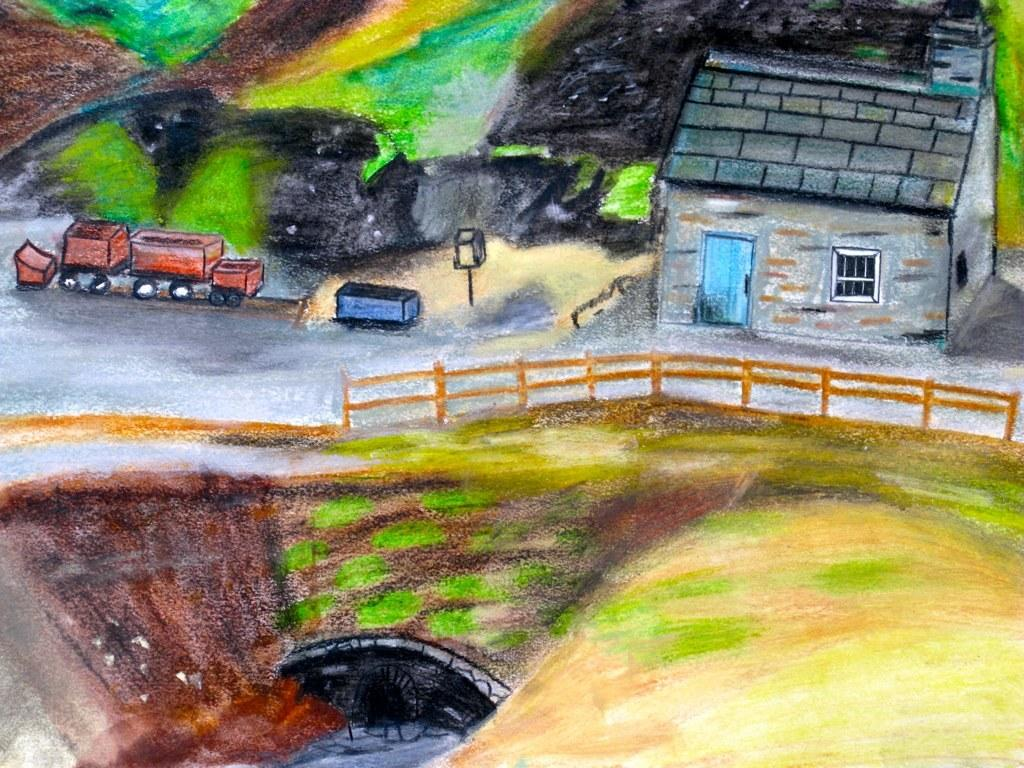What is depicted in the painting in the image? There is a painting of a house in the image. What features can be seen in the painting of the house? There is a fence, a road, vehicles, a door, and a window in the painting. Are there any other objects present in the painting? Yes, there is a pole and other objects in the painting. How many houses are playing baseball in the image? There are no houses or baseball games depicted in the image; it features a painting of a house with various objects and features. How many trees can be seen in the painting? There is no mention of trees in the provided facts, so we cannot determine the number of trees in the painting. 